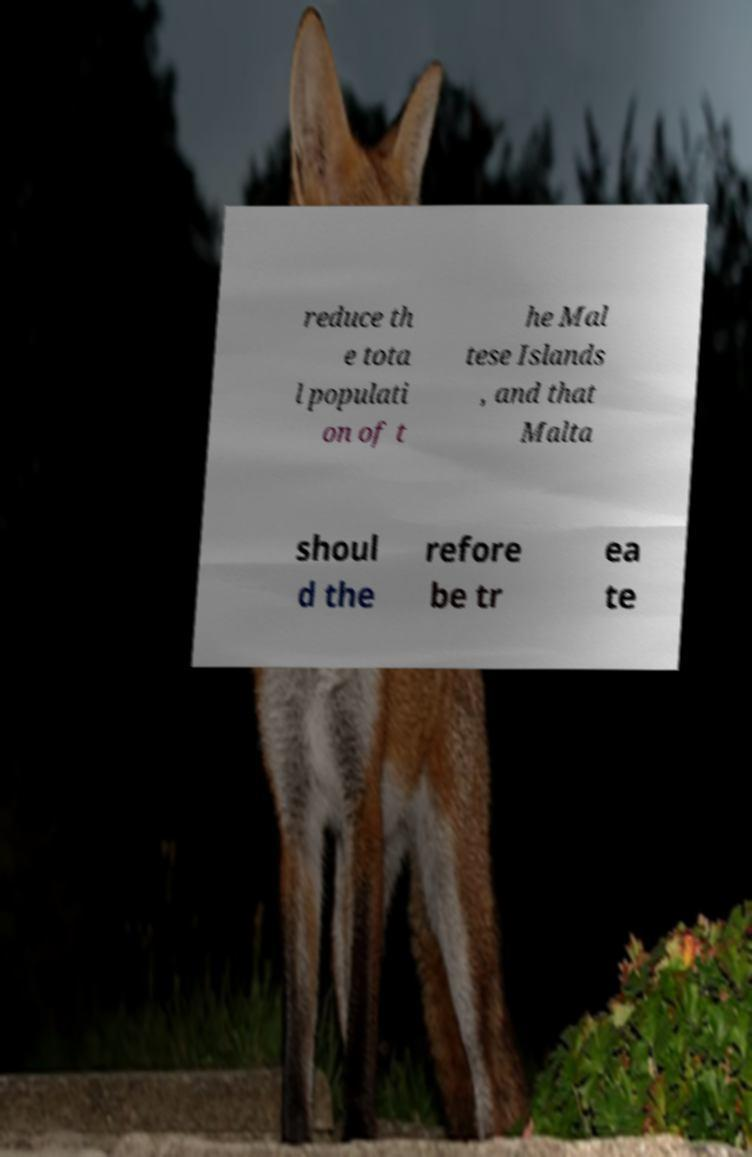For documentation purposes, I need the text within this image transcribed. Could you provide that? reduce th e tota l populati on of t he Mal tese Islands , and that Malta shoul d the refore be tr ea te 